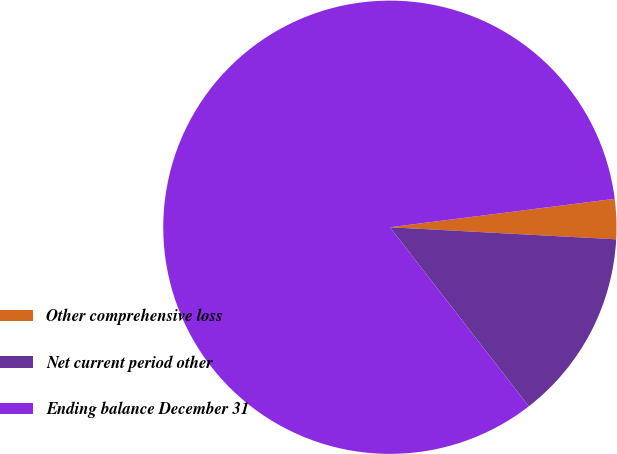Convert chart. <chart><loc_0><loc_0><loc_500><loc_500><pie_chart><fcel>Other comprehensive loss<fcel>Net current period other<fcel>Ending balance December 31<nl><fcel>2.85%<fcel>13.65%<fcel>83.5%<nl></chart> 